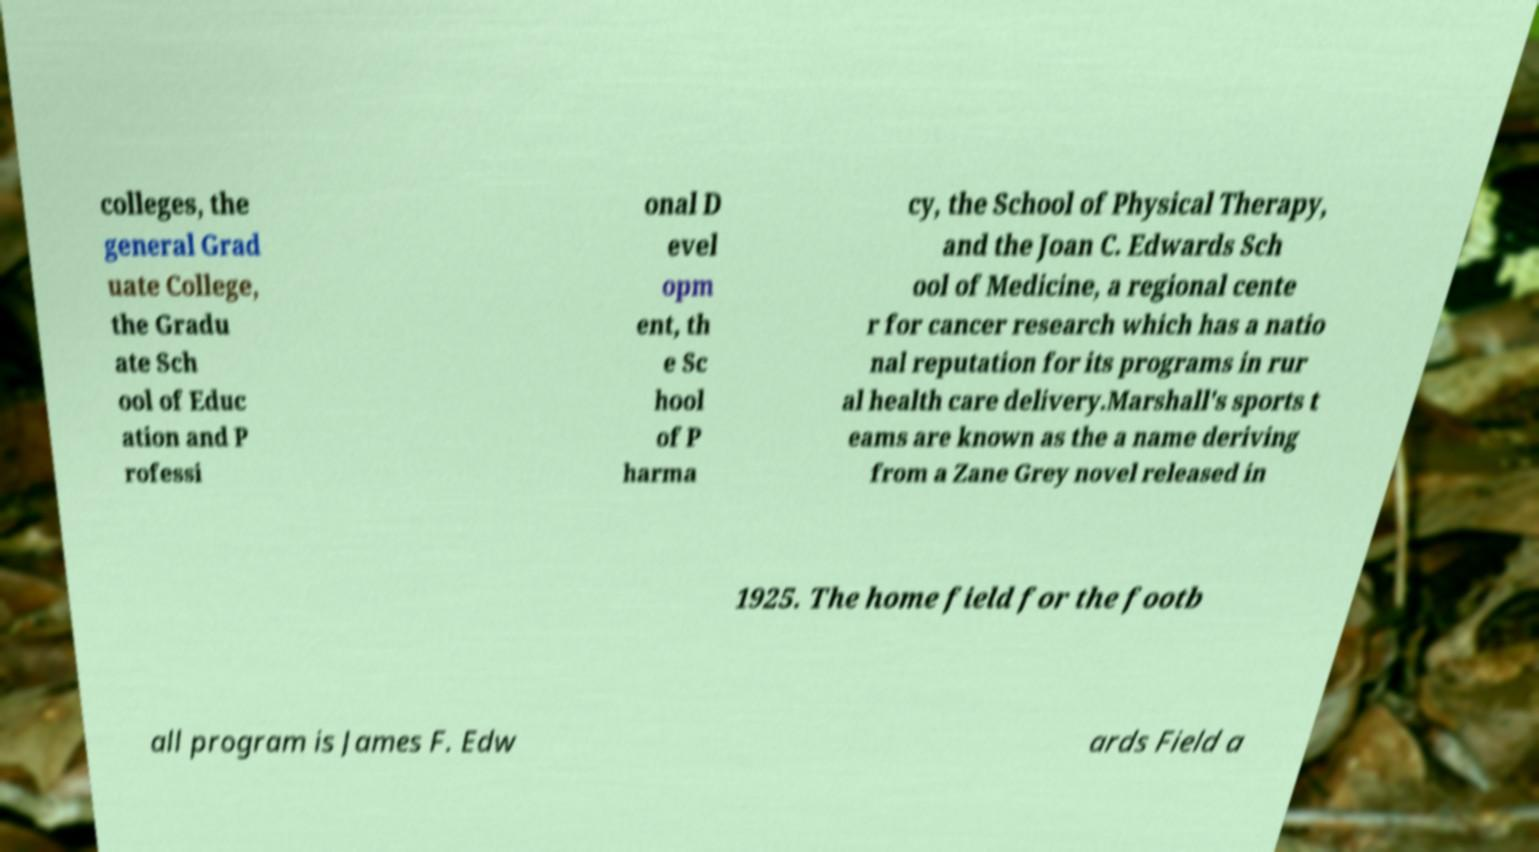There's text embedded in this image that I need extracted. Can you transcribe it verbatim? colleges, the general Grad uate College, the Gradu ate Sch ool of Educ ation and P rofessi onal D evel opm ent, th e Sc hool of P harma cy, the School of Physical Therapy, and the Joan C. Edwards Sch ool of Medicine, a regional cente r for cancer research which has a natio nal reputation for its programs in rur al health care delivery.Marshall's sports t eams are known as the a name deriving from a Zane Grey novel released in 1925. The home field for the footb all program is James F. Edw ards Field a 